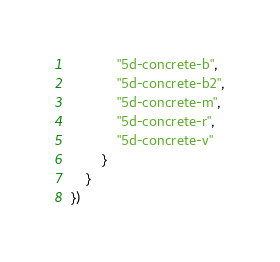Convert code to text. <code><loc_0><loc_0><loc_500><loc_500><_Lua_>			"5d-concrete-b",
			"5d-concrete-b2",
			"5d-concrete-m",
			"5d-concrete-r",
			"5d-concrete-v"
		}
	}
})</code> 